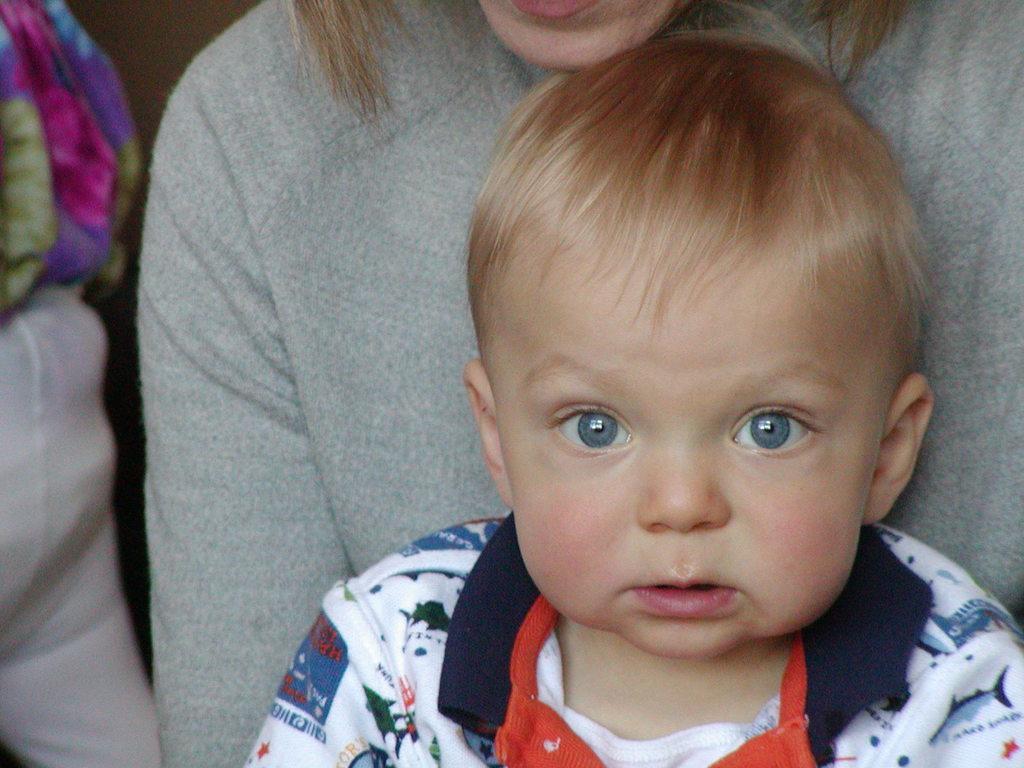In one or two sentences, can you explain what this image depicts? In this picture we can see people and clothes. 